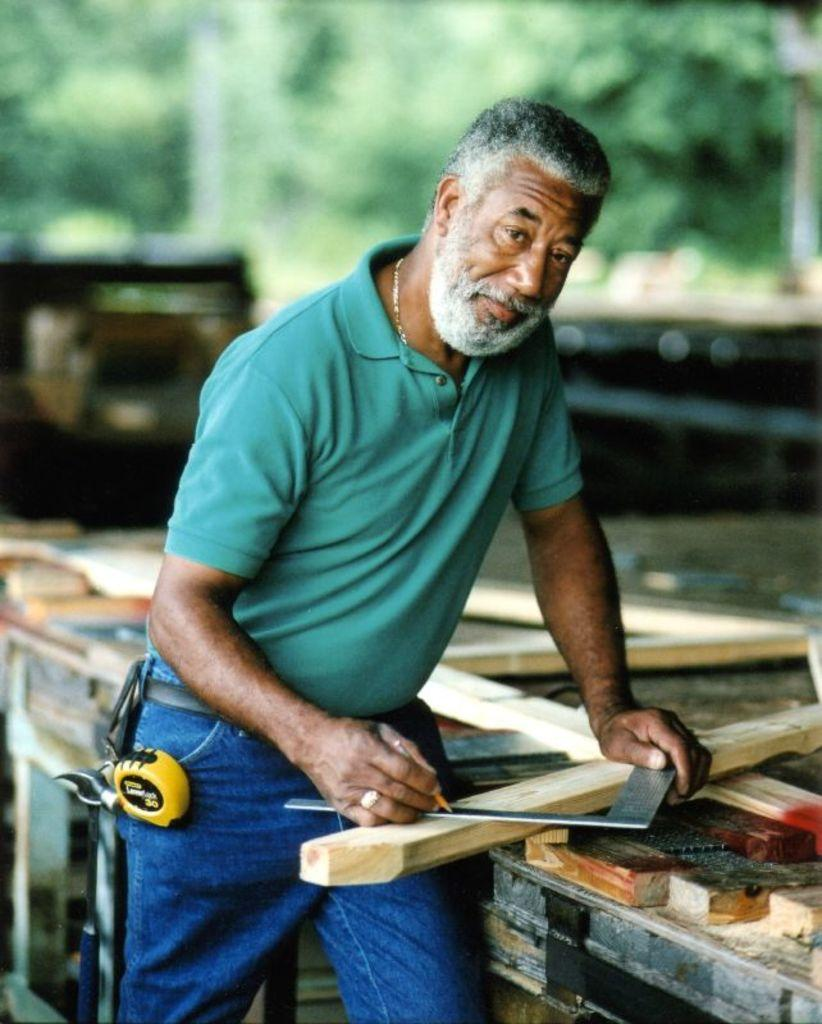What is the occupation of the person in the image? There is a carpenter in the image. What tool is the carpenter holding? The carpenter is holding a pencil. What is the carpenter doing with the pencil? The carpenter is making marks on a piece of wood. What type of roof is the carpenter working on in the image? There is no roof present in the image; the carpenter is making marks on a piece of wood. 